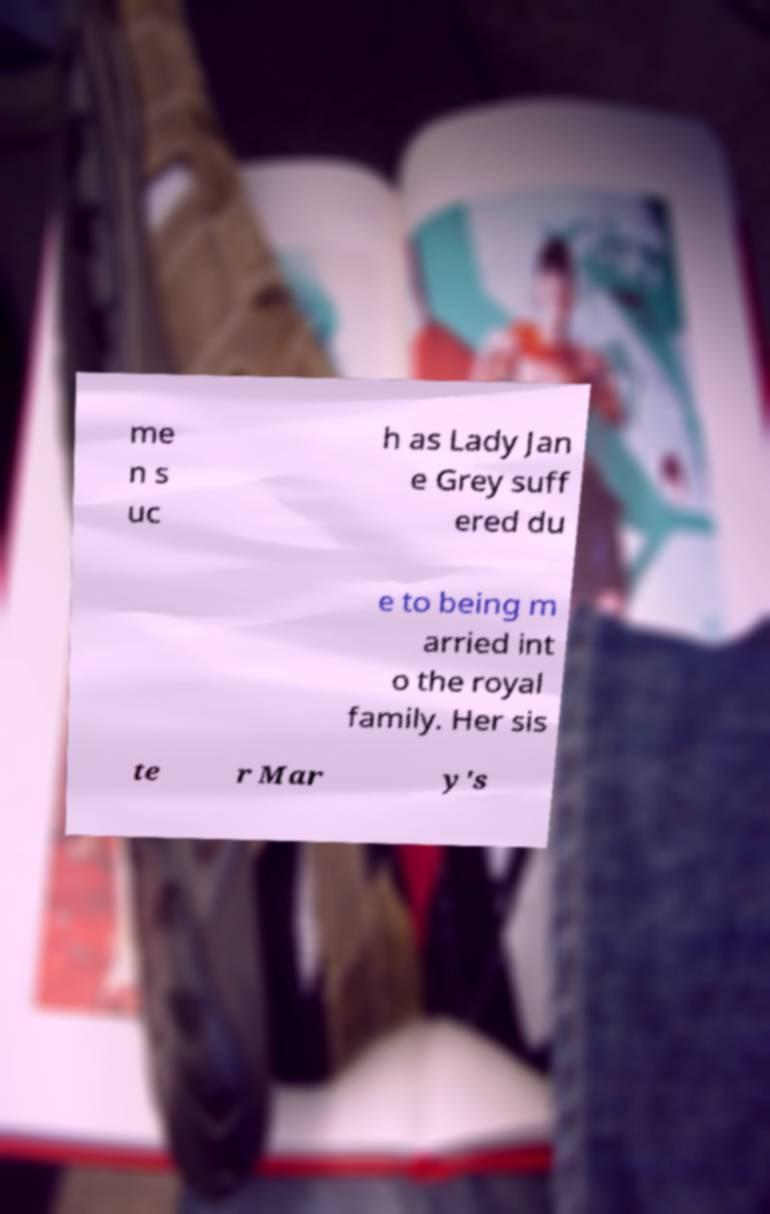For documentation purposes, I need the text within this image transcribed. Could you provide that? me n s uc h as Lady Jan e Grey suff ered du e to being m arried int o the royal family. Her sis te r Mar y's 